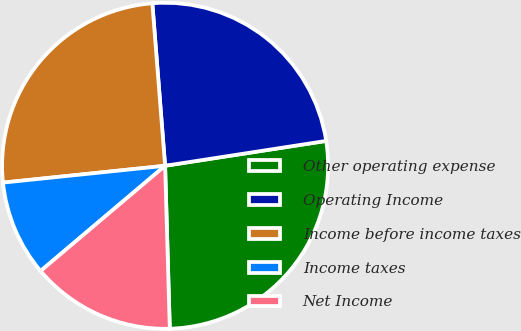<chart> <loc_0><loc_0><loc_500><loc_500><pie_chart><fcel>Other operating expense<fcel>Operating Income<fcel>Income before income taxes<fcel>Income taxes<fcel>Net Income<nl><fcel>26.98%<fcel>23.81%<fcel>25.4%<fcel>9.52%<fcel>14.29%<nl></chart> 